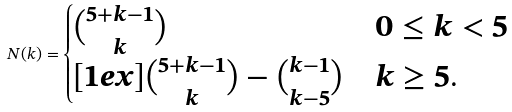Convert formula to latex. <formula><loc_0><loc_0><loc_500><loc_500>N ( k ) = \begin{cases} \binom { 5 + k - 1 } { k } & 0 \leq k < 5 \\ [ 1 e x ] \binom { 5 + k - 1 } { k } - \binom { k - 1 } { k - 5 } & k \geq 5 . \end{cases}</formula> 